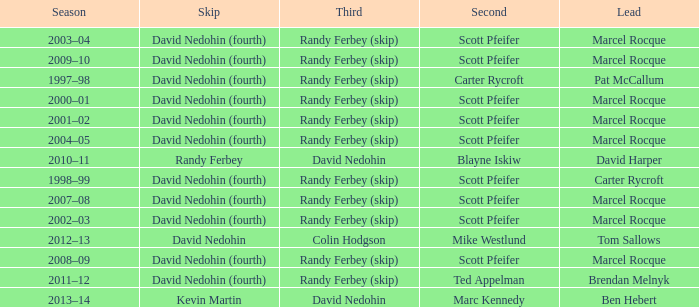Which Second has a Lead of ben hebert? Marc Kennedy. 